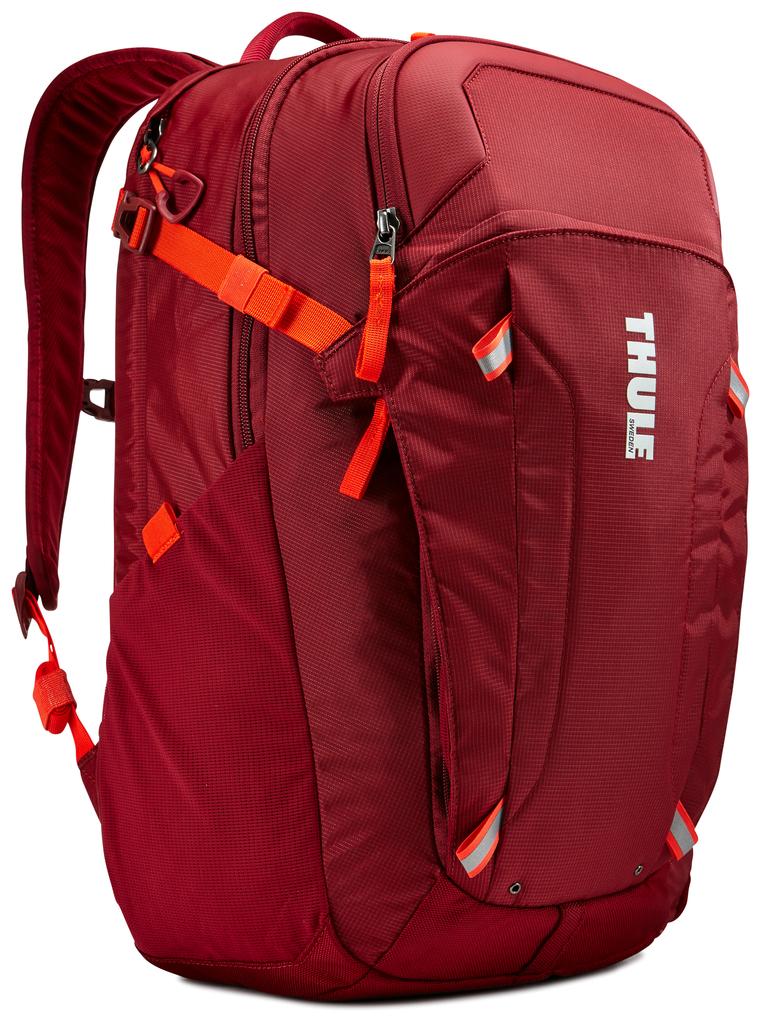What is the word on the letter l say?
Offer a very short reply. Thule. 